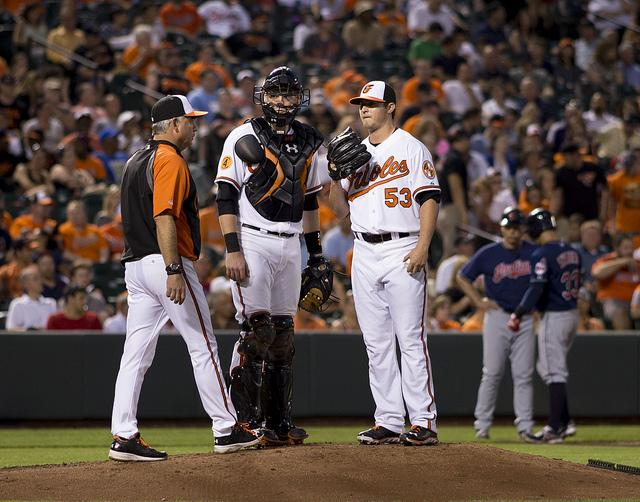Where are the three men in orange and white having their discussion? Please explain your reasoning. pitcher's mound. The men are on the pitchers' mound. 